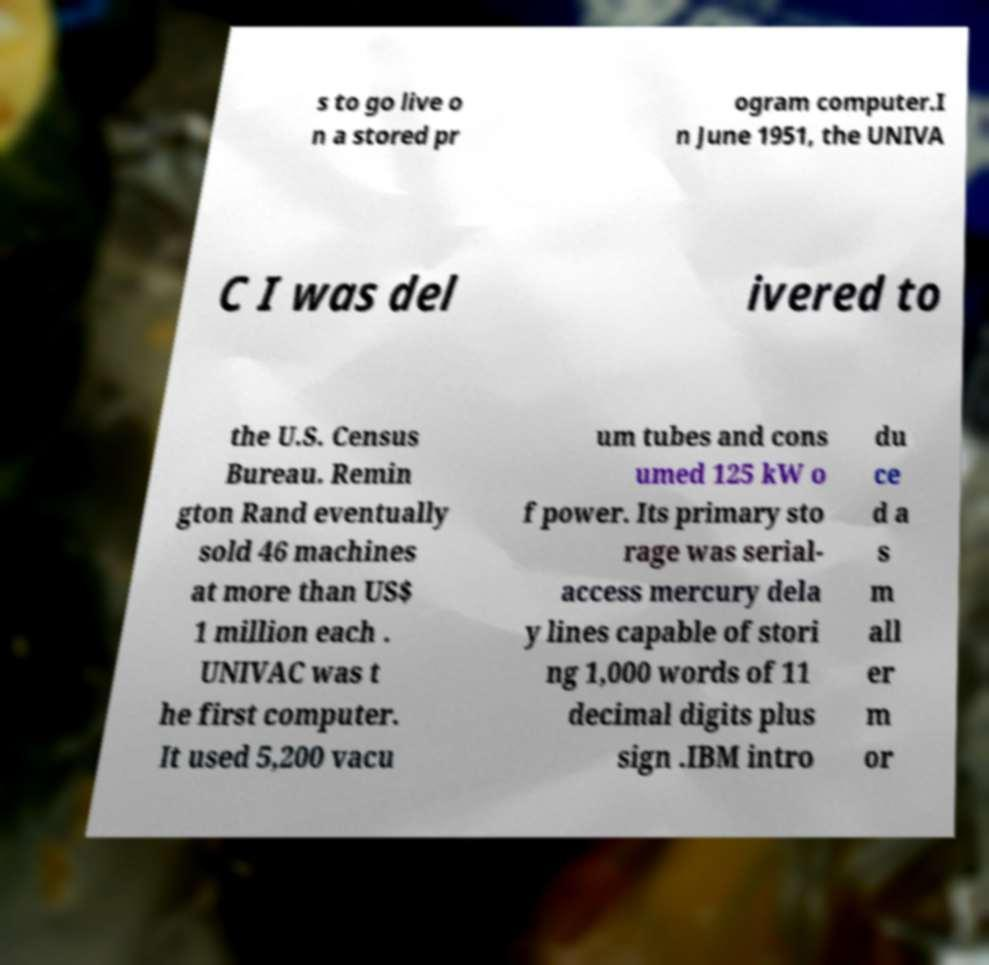What messages or text are displayed in this image? I need them in a readable, typed format. s to go live o n a stored pr ogram computer.I n June 1951, the UNIVA C I was del ivered to the U.S. Census Bureau. Remin gton Rand eventually sold 46 machines at more than US$ 1 million each . UNIVAC was t he first computer. It used 5,200 vacu um tubes and cons umed 125 kW o f power. Its primary sto rage was serial- access mercury dela y lines capable of stori ng 1,000 words of 11 decimal digits plus sign .IBM intro du ce d a s m all er m or 